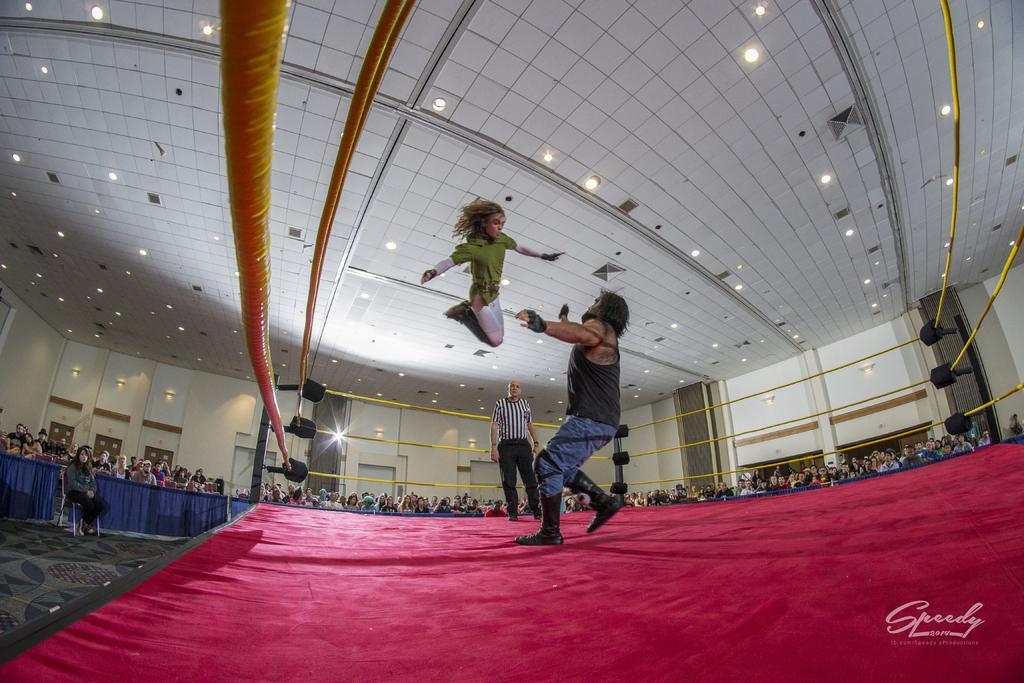Could you give a brief overview of what you see in this image? In this image there are two persons standing on the boxing ring,a person jumping , and at the background there is a person sitting on the chair, carpet, group of people standing, lights. 